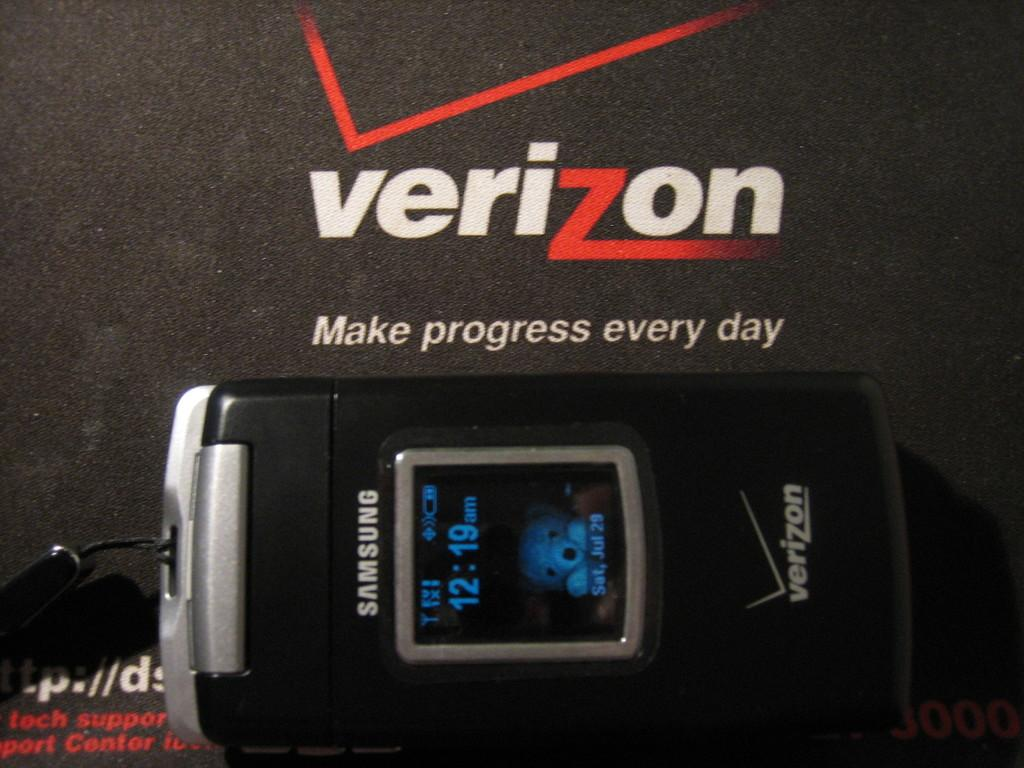<image>
Provide a brief description of the given image. A Samsung Flip Phone with Verizon brand on it. 